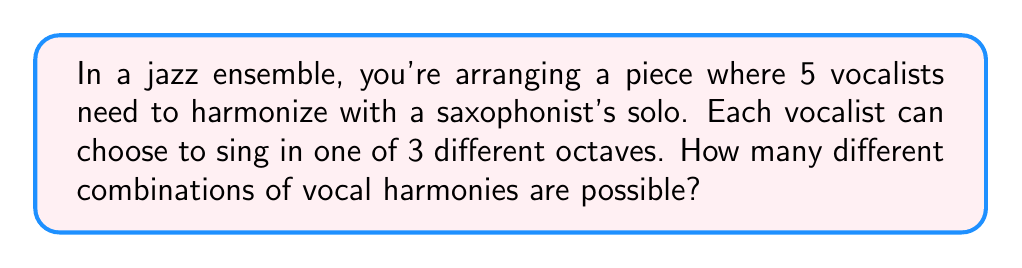Show me your answer to this math problem. Let's approach this step-by-step:

1) We have 5 vocalists, and each vocalist has 3 choices (the 3 different octaves).

2) This is a classic example of the multiplication principle in combinatorics. When we have a series of independent choices, we multiply the number of options for each choice.

3) In this case, we can represent the problem mathematically as:

   $$ 3 \times 3 \times 3 \times 3 \times 3 $$

   This is because each of the 5 vocalists has 3 choices, and their choices are independent of each other.

4) This can be written more concisely using exponent notation:

   $$ 3^5 $$

5) To calculate this:
   $$ 3^5 = 3 \times 3 \times 3 \times 3 \times 3 = 243 $$

Thus, there are 243 different possible combinations of vocal harmonies.
Answer: 243 